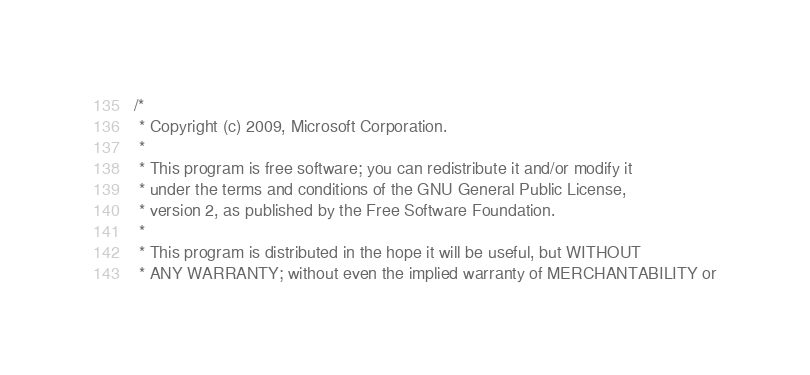Convert code to text. <code><loc_0><loc_0><loc_500><loc_500><_C_>/*
 * Copyright (c) 2009, Microsoft Corporation.
 *
 * This program is free software; you can redistribute it and/or modify it
 * under the terms and conditions of the GNU General Public License,
 * version 2, as published by the Free Software Foundation.
 *
 * This program is distributed in the hope it will be useful, but WITHOUT
 * ANY WARRANTY; without even the implied warranty of MERCHANTABILITY or</code> 